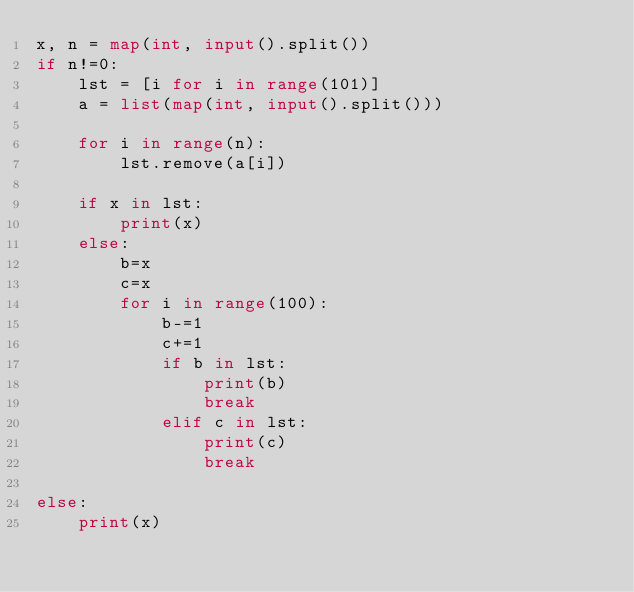<code> <loc_0><loc_0><loc_500><loc_500><_Python_>x, n = map(int, input().split())
if n!=0:
    lst = [i for i in range(101)]
    a = list(map(int, input().split()))

    for i in range(n):
        lst.remove(a[i])
    
    if x in lst:
        print(x)
    else:
        b=x
        c=x
        for i in range(100):
            b-=1
            c+=1
            if b in lst:
                print(b)
                break
            elif c in lst:
                print(c)
                break
    
else:
    print(x)</code> 